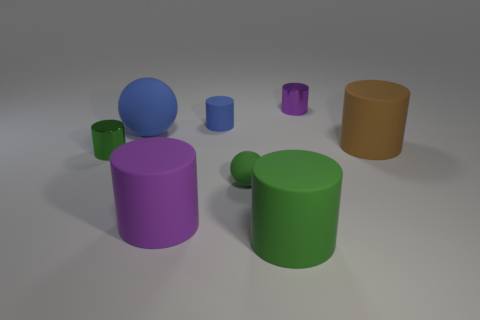Subtract all red blocks. How many green cylinders are left? 2 Subtract all blue cylinders. How many cylinders are left? 5 Subtract all brown cylinders. How many cylinders are left? 5 Add 1 purple metal balls. How many objects exist? 9 Subtract all red cylinders. Subtract all brown spheres. How many cylinders are left? 6 Subtract 0 yellow cubes. How many objects are left? 8 Subtract all balls. How many objects are left? 6 Subtract all large green things. Subtract all small red matte balls. How many objects are left? 7 Add 5 small purple metal cylinders. How many small purple metal cylinders are left? 6 Add 3 red matte spheres. How many red matte spheres exist? 3 